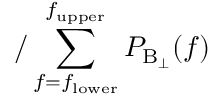<formula> <loc_0><loc_0><loc_500><loc_500>/ \sum _ { f = f _ { l o w e r } } ^ { f _ { u p p e r } } P _ { B _ { \perp } } ( f )</formula> 